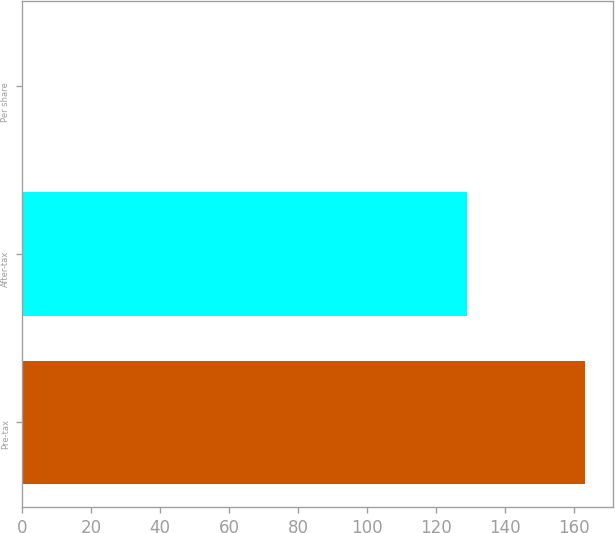Convert chart to OTSL. <chart><loc_0><loc_0><loc_500><loc_500><bar_chart><fcel>Pre-tax<fcel>After-tax<fcel>Per share<nl><fcel>163<fcel>129<fcel>0.08<nl></chart> 